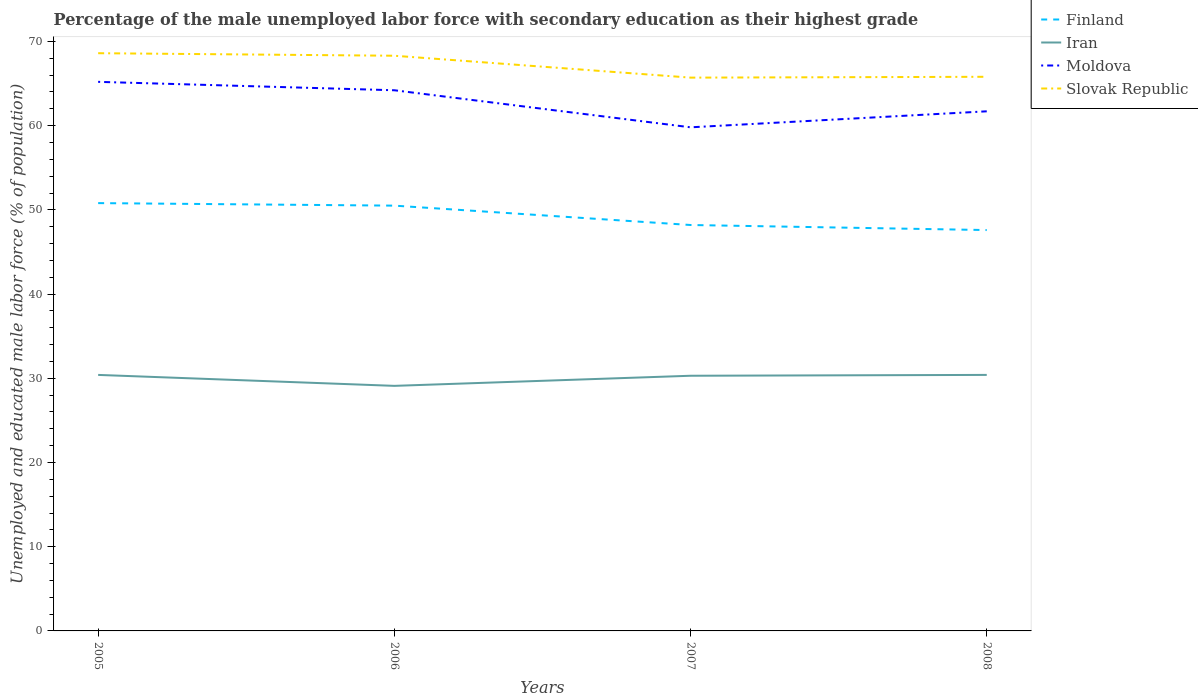How many different coloured lines are there?
Provide a short and direct response. 4. Across all years, what is the maximum percentage of the unemployed male labor force with secondary education in Slovak Republic?
Offer a terse response. 65.7. In which year was the percentage of the unemployed male labor force with secondary education in Finland maximum?
Ensure brevity in your answer.  2008. What is the total percentage of the unemployed male labor force with secondary education in Iran in the graph?
Provide a succinct answer. -1.3. What is the difference between the highest and the second highest percentage of the unemployed male labor force with secondary education in Finland?
Provide a succinct answer. 3.2. Is the percentage of the unemployed male labor force with secondary education in Iran strictly greater than the percentage of the unemployed male labor force with secondary education in Moldova over the years?
Offer a very short reply. Yes. How many lines are there?
Offer a very short reply. 4. Are the values on the major ticks of Y-axis written in scientific E-notation?
Your answer should be very brief. No. Does the graph contain grids?
Keep it short and to the point. No. Where does the legend appear in the graph?
Ensure brevity in your answer.  Top right. How many legend labels are there?
Provide a succinct answer. 4. How are the legend labels stacked?
Your answer should be very brief. Vertical. What is the title of the graph?
Make the answer very short. Percentage of the male unemployed labor force with secondary education as their highest grade. What is the label or title of the X-axis?
Provide a short and direct response. Years. What is the label or title of the Y-axis?
Your answer should be very brief. Unemployed and educated male labor force (% of population). What is the Unemployed and educated male labor force (% of population) of Finland in 2005?
Give a very brief answer. 50.8. What is the Unemployed and educated male labor force (% of population) of Iran in 2005?
Ensure brevity in your answer.  30.4. What is the Unemployed and educated male labor force (% of population) in Moldova in 2005?
Your response must be concise. 65.2. What is the Unemployed and educated male labor force (% of population) of Slovak Republic in 2005?
Keep it short and to the point. 68.6. What is the Unemployed and educated male labor force (% of population) of Finland in 2006?
Ensure brevity in your answer.  50.5. What is the Unemployed and educated male labor force (% of population) of Iran in 2006?
Offer a very short reply. 29.1. What is the Unemployed and educated male labor force (% of population) in Moldova in 2006?
Make the answer very short. 64.2. What is the Unemployed and educated male labor force (% of population) of Slovak Republic in 2006?
Your answer should be very brief. 68.3. What is the Unemployed and educated male labor force (% of population) of Finland in 2007?
Your answer should be compact. 48.2. What is the Unemployed and educated male labor force (% of population) in Iran in 2007?
Offer a terse response. 30.3. What is the Unemployed and educated male labor force (% of population) of Moldova in 2007?
Keep it short and to the point. 59.8. What is the Unemployed and educated male labor force (% of population) of Slovak Republic in 2007?
Your response must be concise. 65.7. What is the Unemployed and educated male labor force (% of population) in Finland in 2008?
Ensure brevity in your answer.  47.6. What is the Unemployed and educated male labor force (% of population) of Iran in 2008?
Your answer should be compact. 30.4. What is the Unemployed and educated male labor force (% of population) of Moldova in 2008?
Your answer should be compact. 61.7. What is the Unemployed and educated male labor force (% of population) in Slovak Republic in 2008?
Ensure brevity in your answer.  65.8. Across all years, what is the maximum Unemployed and educated male labor force (% of population) of Finland?
Make the answer very short. 50.8. Across all years, what is the maximum Unemployed and educated male labor force (% of population) of Iran?
Make the answer very short. 30.4. Across all years, what is the maximum Unemployed and educated male labor force (% of population) of Moldova?
Provide a succinct answer. 65.2. Across all years, what is the maximum Unemployed and educated male labor force (% of population) of Slovak Republic?
Keep it short and to the point. 68.6. Across all years, what is the minimum Unemployed and educated male labor force (% of population) in Finland?
Keep it short and to the point. 47.6. Across all years, what is the minimum Unemployed and educated male labor force (% of population) of Iran?
Keep it short and to the point. 29.1. Across all years, what is the minimum Unemployed and educated male labor force (% of population) in Moldova?
Make the answer very short. 59.8. Across all years, what is the minimum Unemployed and educated male labor force (% of population) in Slovak Republic?
Make the answer very short. 65.7. What is the total Unemployed and educated male labor force (% of population) of Finland in the graph?
Keep it short and to the point. 197.1. What is the total Unemployed and educated male labor force (% of population) in Iran in the graph?
Keep it short and to the point. 120.2. What is the total Unemployed and educated male labor force (% of population) of Moldova in the graph?
Give a very brief answer. 250.9. What is the total Unemployed and educated male labor force (% of population) of Slovak Republic in the graph?
Keep it short and to the point. 268.4. What is the difference between the Unemployed and educated male labor force (% of population) of Finland in 2005 and that in 2006?
Ensure brevity in your answer.  0.3. What is the difference between the Unemployed and educated male labor force (% of population) of Iran in 2005 and that in 2006?
Provide a short and direct response. 1.3. What is the difference between the Unemployed and educated male labor force (% of population) in Moldova in 2005 and that in 2006?
Make the answer very short. 1. What is the difference between the Unemployed and educated male labor force (% of population) of Slovak Republic in 2005 and that in 2006?
Offer a very short reply. 0.3. What is the difference between the Unemployed and educated male labor force (% of population) of Finland in 2005 and that in 2007?
Make the answer very short. 2.6. What is the difference between the Unemployed and educated male labor force (% of population) of Moldova in 2005 and that in 2007?
Your answer should be very brief. 5.4. What is the difference between the Unemployed and educated male labor force (% of population) in Slovak Republic in 2005 and that in 2007?
Ensure brevity in your answer.  2.9. What is the difference between the Unemployed and educated male labor force (% of population) in Moldova in 2005 and that in 2008?
Make the answer very short. 3.5. What is the difference between the Unemployed and educated male labor force (% of population) of Slovak Republic in 2005 and that in 2008?
Keep it short and to the point. 2.8. What is the difference between the Unemployed and educated male labor force (% of population) of Finland in 2006 and that in 2007?
Your answer should be very brief. 2.3. What is the difference between the Unemployed and educated male labor force (% of population) in Moldova in 2006 and that in 2007?
Provide a succinct answer. 4.4. What is the difference between the Unemployed and educated male labor force (% of population) of Slovak Republic in 2006 and that in 2007?
Your answer should be compact. 2.6. What is the difference between the Unemployed and educated male labor force (% of population) in Finland in 2006 and that in 2008?
Your answer should be very brief. 2.9. What is the difference between the Unemployed and educated male labor force (% of population) in Slovak Republic in 2006 and that in 2008?
Ensure brevity in your answer.  2.5. What is the difference between the Unemployed and educated male labor force (% of population) in Iran in 2007 and that in 2008?
Your answer should be compact. -0.1. What is the difference between the Unemployed and educated male labor force (% of population) of Slovak Republic in 2007 and that in 2008?
Provide a succinct answer. -0.1. What is the difference between the Unemployed and educated male labor force (% of population) of Finland in 2005 and the Unemployed and educated male labor force (% of population) of Iran in 2006?
Ensure brevity in your answer.  21.7. What is the difference between the Unemployed and educated male labor force (% of population) in Finland in 2005 and the Unemployed and educated male labor force (% of population) in Moldova in 2006?
Make the answer very short. -13.4. What is the difference between the Unemployed and educated male labor force (% of population) of Finland in 2005 and the Unemployed and educated male labor force (% of population) of Slovak Republic in 2006?
Offer a terse response. -17.5. What is the difference between the Unemployed and educated male labor force (% of population) of Iran in 2005 and the Unemployed and educated male labor force (% of population) of Moldova in 2006?
Make the answer very short. -33.8. What is the difference between the Unemployed and educated male labor force (% of population) of Iran in 2005 and the Unemployed and educated male labor force (% of population) of Slovak Republic in 2006?
Keep it short and to the point. -37.9. What is the difference between the Unemployed and educated male labor force (% of population) in Finland in 2005 and the Unemployed and educated male labor force (% of population) in Iran in 2007?
Provide a short and direct response. 20.5. What is the difference between the Unemployed and educated male labor force (% of population) in Finland in 2005 and the Unemployed and educated male labor force (% of population) in Moldova in 2007?
Ensure brevity in your answer.  -9. What is the difference between the Unemployed and educated male labor force (% of population) in Finland in 2005 and the Unemployed and educated male labor force (% of population) in Slovak Republic in 2007?
Ensure brevity in your answer.  -14.9. What is the difference between the Unemployed and educated male labor force (% of population) in Iran in 2005 and the Unemployed and educated male labor force (% of population) in Moldova in 2007?
Your response must be concise. -29.4. What is the difference between the Unemployed and educated male labor force (% of population) of Iran in 2005 and the Unemployed and educated male labor force (% of population) of Slovak Republic in 2007?
Give a very brief answer. -35.3. What is the difference between the Unemployed and educated male labor force (% of population) of Finland in 2005 and the Unemployed and educated male labor force (% of population) of Iran in 2008?
Provide a succinct answer. 20.4. What is the difference between the Unemployed and educated male labor force (% of population) of Iran in 2005 and the Unemployed and educated male labor force (% of population) of Moldova in 2008?
Provide a succinct answer. -31.3. What is the difference between the Unemployed and educated male labor force (% of population) of Iran in 2005 and the Unemployed and educated male labor force (% of population) of Slovak Republic in 2008?
Make the answer very short. -35.4. What is the difference between the Unemployed and educated male labor force (% of population) of Finland in 2006 and the Unemployed and educated male labor force (% of population) of Iran in 2007?
Ensure brevity in your answer.  20.2. What is the difference between the Unemployed and educated male labor force (% of population) in Finland in 2006 and the Unemployed and educated male labor force (% of population) in Slovak Republic in 2007?
Keep it short and to the point. -15.2. What is the difference between the Unemployed and educated male labor force (% of population) of Iran in 2006 and the Unemployed and educated male labor force (% of population) of Moldova in 2007?
Make the answer very short. -30.7. What is the difference between the Unemployed and educated male labor force (% of population) in Iran in 2006 and the Unemployed and educated male labor force (% of population) in Slovak Republic in 2007?
Provide a succinct answer. -36.6. What is the difference between the Unemployed and educated male labor force (% of population) in Finland in 2006 and the Unemployed and educated male labor force (% of population) in Iran in 2008?
Your response must be concise. 20.1. What is the difference between the Unemployed and educated male labor force (% of population) in Finland in 2006 and the Unemployed and educated male labor force (% of population) in Slovak Republic in 2008?
Your response must be concise. -15.3. What is the difference between the Unemployed and educated male labor force (% of population) in Iran in 2006 and the Unemployed and educated male labor force (% of population) in Moldova in 2008?
Offer a terse response. -32.6. What is the difference between the Unemployed and educated male labor force (% of population) of Iran in 2006 and the Unemployed and educated male labor force (% of population) of Slovak Republic in 2008?
Your answer should be compact. -36.7. What is the difference between the Unemployed and educated male labor force (% of population) of Finland in 2007 and the Unemployed and educated male labor force (% of population) of Iran in 2008?
Keep it short and to the point. 17.8. What is the difference between the Unemployed and educated male labor force (% of population) of Finland in 2007 and the Unemployed and educated male labor force (% of population) of Slovak Republic in 2008?
Your answer should be very brief. -17.6. What is the difference between the Unemployed and educated male labor force (% of population) in Iran in 2007 and the Unemployed and educated male labor force (% of population) in Moldova in 2008?
Your response must be concise. -31.4. What is the difference between the Unemployed and educated male labor force (% of population) of Iran in 2007 and the Unemployed and educated male labor force (% of population) of Slovak Republic in 2008?
Your answer should be very brief. -35.5. What is the average Unemployed and educated male labor force (% of population) of Finland per year?
Your answer should be very brief. 49.27. What is the average Unemployed and educated male labor force (% of population) of Iran per year?
Make the answer very short. 30.05. What is the average Unemployed and educated male labor force (% of population) of Moldova per year?
Give a very brief answer. 62.73. What is the average Unemployed and educated male labor force (% of population) of Slovak Republic per year?
Provide a short and direct response. 67.1. In the year 2005, what is the difference between the Unemployed and educated male labor force (% of population) in Finland and Unemployed and educated male labor force (% of population) in Iran?
Provide a succinct answer. 20.4. In the year 2005, what is the difference between the Unemployed and educated male labor force (% of population) in Finland and Unemployed and educated male labor force (% of population) in Moldova?
Make the answer very short. -14.4. In the year 2005, what is the difference between the Unemployed and educated male labor force (% of population) of Finland and Unemployed and educated male labor force (% of population) of Slovak Republic?
Ensure brevity in your answer.  -17.8. In the year 2005, what is the difference between the Unemployed and educated male labor force (% of population) in Iran and Unemployed and educated male labor force (% of population) in Moldova?
Provide a short and direct response. -34.8. In the year 2005, what is the difference between the Unemployed and educated male labor force (% of population) in Iran and Unemployed and educated male labor force (% of population) in Slovak Republic?
Ensure brevity in your answer.  -38.2. In the year 2006, what is the difference between the Unemployed and educated male labor force (% of population) in Finland and Unemployed and educated male labor force (% of population) in Iran?
Keep it short and to the point. 21.4. In the year 2006, what is the difference between the Unemployed and educated male labor force (% of population) of Finland and Unemployed and educated male labor force (% of population) of Moldova?
Keep it short and to the point. -13.7. In the year 2006, what is the difference between the Unemployed and educated male labor force (% of population) of Finland and Unemployed and educated male labor force (% of population) of Slovak Republic?
Your answer should be very brief. -17.8. In the year 2006, what is the difference between the Unemployed and educated male labor force (% of population) of Iran and Unemployed and educated male labor force (% of population) of Moldova?
Give a very brief answer. -35.1. In the year 2006, what is the difference between the Unemployed and educated male labor force (% of population) in Iran and Unemployed and educated male labor force (% of population) in Slovak Republic?
Keep it short and to the point. -39.2. In the year 2007, what is the difference between the Unemployed and educated male labor force (% of population) in Finland and Unemployed and educated male labor force (% of population) in Slovak Republic?
Provide a short and direct response. -17.5. In the year 2007, what is the difference between the Unemployed and educated male labor force (% of population) of Iran and Unemployed and educated male labor force (% of population) of Moldova?
Make the answer very short. -29.5. In the year 2007, what is the difference between the Unemployed and educated male labor force (% of population) of Iran and Unemployed and educated male labor force (% of population) of Slovak Republic?
Offer a very short reply. -35.4. In the year 2007, what is the difference between the Unemployed and educated male labor force (% of population) in Moldova and Unemployed and educated male labor force (% of population) in Slovak Republic?
Your answer should be very brief. -5.9. In the year 2008, what is the difference between the Unemployed and educated male labor force (% of population) of Finland and Unemployed and educated male labor force (% of population) of Iran?
Your response must be concise. 17.2. In the year 2008, what is the difference between the Unemployed and educated male labor force (% of population) of Finland and Unemployed and educated male labor force (% of population) of Moldova?
Offer a terse response. -14.1. In the year 2008, what is the difference between the Unemployed and educated male labor force (% of population) in Finland and Unemployed and educated male labor force (% of population) in Slovak Republic?
Keep it short and to the point. -18.2. In the year 2008, what is the difference between the Unemployed and educated male labor force (% of population) in Iran and Unemployed and educated male labor force (% of population) in Moldova?
Keep it short and to the point. -31.3. In the year 2008, what is the difference between the Unemployed and educated male labor force (% of population) in Iran and Unemployed and educated male labor force (% of population) in Slovak Republic?
Your response must be concise. -35.4. In the year 2008, what is the difference between the Unemployed and educated male labor force (% of population) in Moldova and Unemployed and educated male labor force (% of population) in Slovak Republic?
Offer a very short reply. -4.1. What is the ratio of the Unemployed and educated male labor force (% of population) of Finland in 2005 to that in 2006?
Keep it short and to the point. 1.01. What is the ratio of the Unemployed and educated male labor force (% of population) in Iran in 2005 to that in 2006?
Make the answer very short. 1.04. What is the ratio of the Unemployed and educated male labor force (% of population) in Moldova in 2005 to that in 2006?
Offer a terse response. 1.02. What is the ratio of the Unemployed and educated male labor force (% of population) of Finland in 2005 to that in 2007?
Your answer should be compact. 1.05. What is the ratio of the Unemployed and educated male labor force (% of population) in Iran in 2005 to that in 2007?
Offer a very short reply. 1. What is the ratio of the Unemployed and educated male labor force (% of population) of Moldova in 2005 to that in 2007?
Ensure brevity in your answer.  1.09. What is the ratio of the Unemployed and educated male labor force (% of population) in Slovak Republic in 2005 to that in 2007?
Provide a succinct answer. 1.04. What is the ratio of the Unemployed and educated male labor force (% of population) of Finland in 2005 to that in 2008?
Provide a succinct answer. 1.07. What is the ratio of the Unemployed and educated male labor force (% of population) in Moldova in 2005 to that in 2008?
Your answer should be very brief. 1.06. What is the ratio of the Unemployed and educated male labor force (% of population) in Slovak Republic in 2005 to that in 2008?
Provide a succinct answer. 1.04. What is the ratio of the Unemployed and educated male labor force (% of population) of Finland in 2006 to that in 2007?
Provide a succinct answer. 1.05. What is the ratio of the Unemployed and educated male labor force (% of population) in Iran in 2006 to that in 2007?
Your response must be concise. 0.96. What is the ratio of the Unemployed and educated male labor force (% of population) in Moldova in 2006 to that in 2007?
Make the answer very short. 1.07. What is the ratio of the Unemployed and educated male labor force (% of population) in Slovak Republic in 2006 to that in 2007?
Provide a short and direct response. 1.04. What is the ratio of the Unemployed and educated male labor force (% of population) of Finland in 2006 to that in 2008?
Provide a short and direct response. 1.06. What is the ratio of the Unemployed and educated male labor force (% of population) of Iran in 2006 to that in 2008?
Give a very brief answer. 0.96. What is the ratio of the Unemployed and educated male labor force (% of population) of Moldova in 2006 to that in 2008?
Your answer should be very brief. 1.04. What is the ratio of the Unemployed and educated male labor force (% of population) of Slovak Republic in 2006 to that in 2008?
Keep it short and to the point. 1.04. What is the ratio of the Unemployed and educated male labor force (% of population) in Finland in 2007 to that in 2008?
Your response must be concise. 1.01. What is the ratio of the Unemployed and educated male labor force (% of population) in Moldova in 2007 to that in 2008?
Make the answer very short. 0.97. What is the difference between the highest and the second highest Unemployed and educated male labor force (% of population) of Finland?
Provide a short and direct response. 0.3. What is the difference between the highest and the second highest Unemployed and educated male labor force (% of population) of Iran?
Keep it short and to the point. 0. What is the difference between the highest and the lowest Unemployed and educated male labor force (% of population) in Finland?
Ensure brevity in your answer.  3.2. 